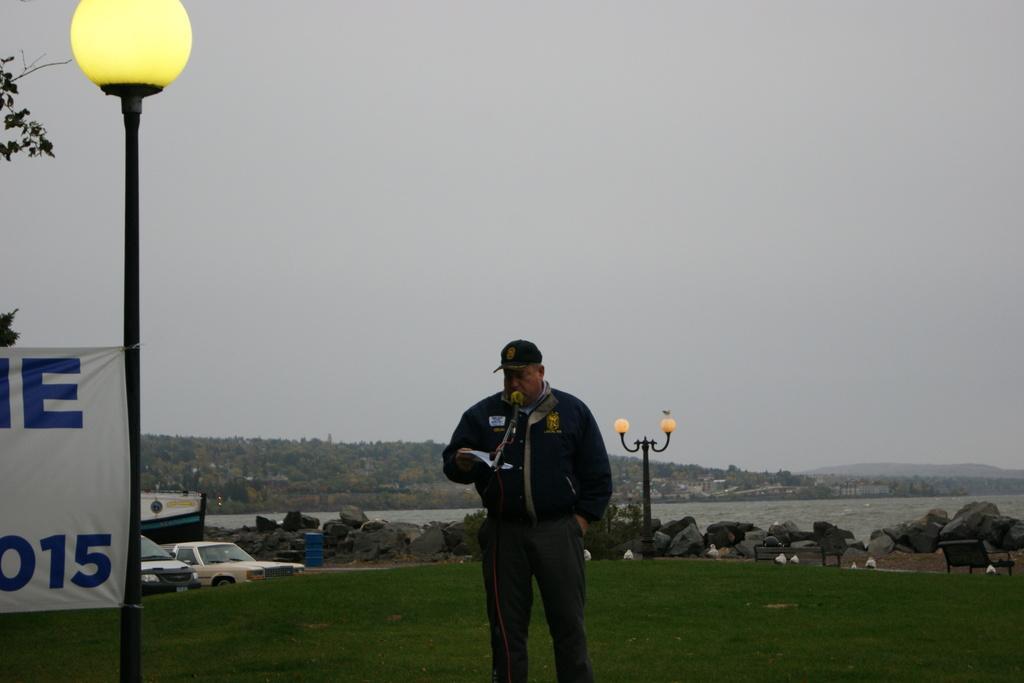Describe this image in one or two sentences. In the center of the image we can see a man standing and holding a paper in his hand, before him there is a mic. On the left there is a pole and a banner. In the background there are cars, rocks, lights, hills, river and sky. 